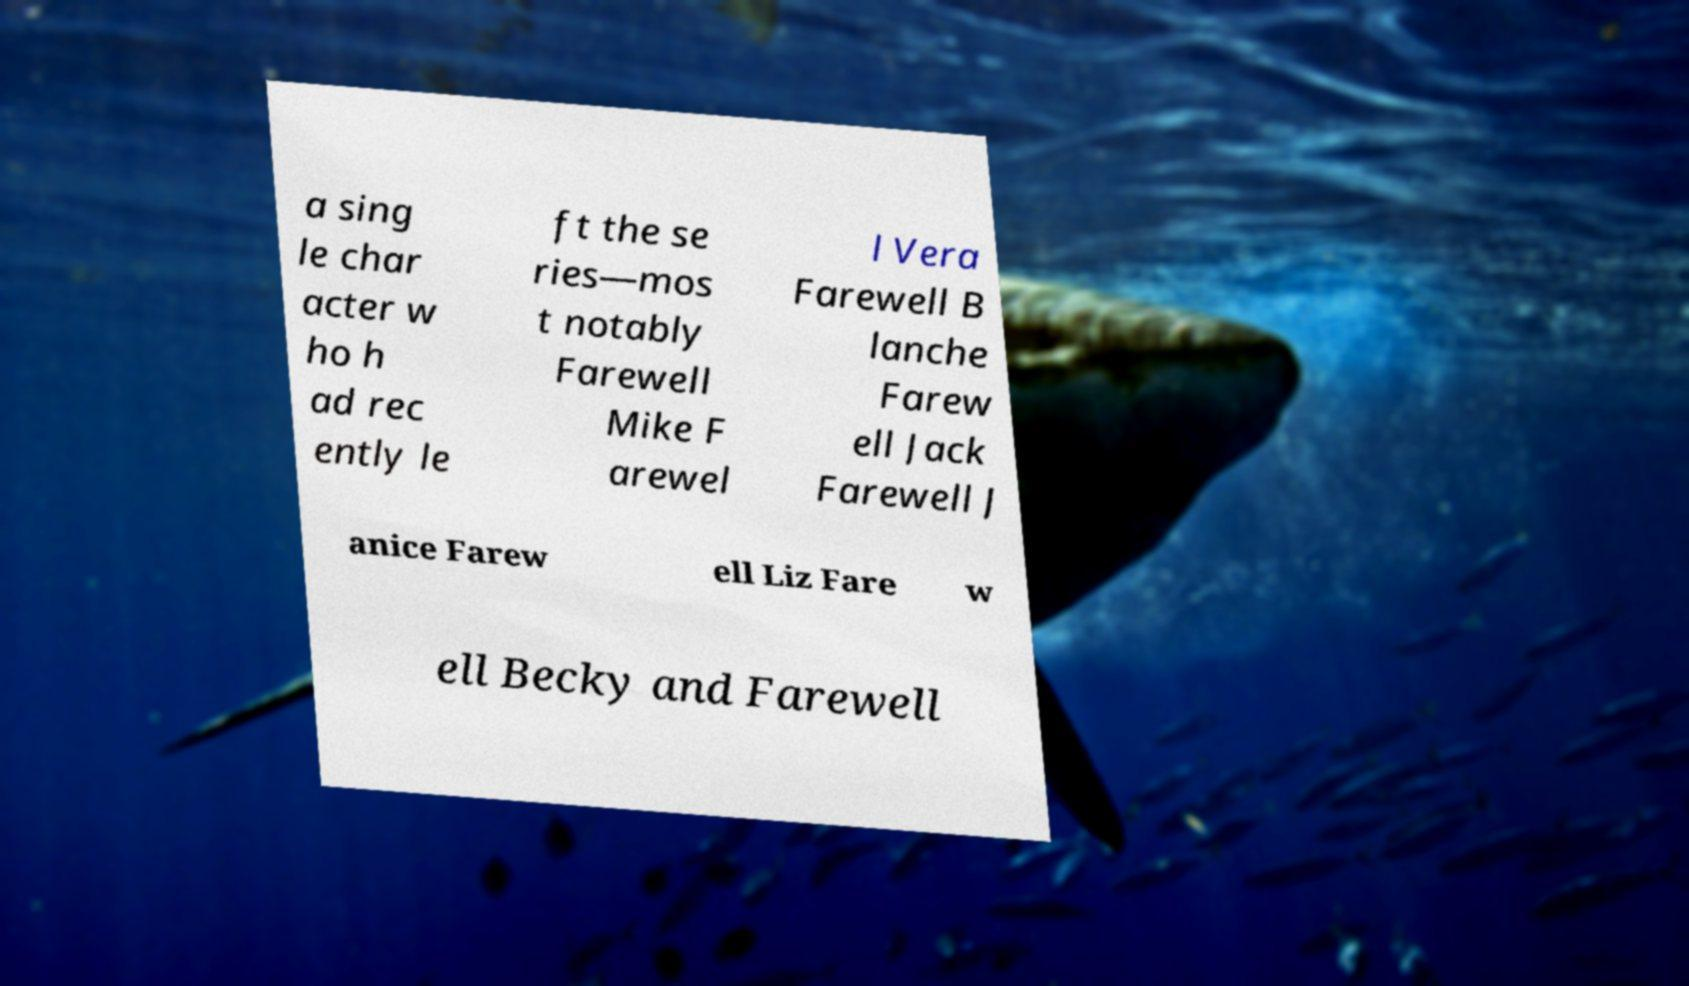Could you extract and type out the text from this image? a sing le char acter w ho h ad rec ently le ft the se ries—mos t notably Farewell Mike F arewel l Vera Farewell B lanche Farew ell Jack Farewell J anice Farew ell Liz Fare w ell Becky and Farewell 